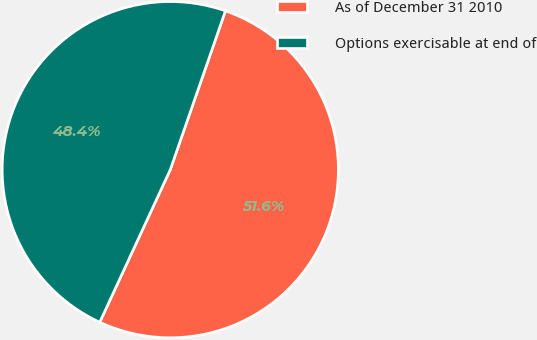Convert chart. <chart><loc_0><loc_0><loc_500><loc_500><pie_chart><fcel>As of December 31 2010<fcel>Options exercisable at end of<nl><fcel>51.57%<fcel>48.43%<nl></chart> 